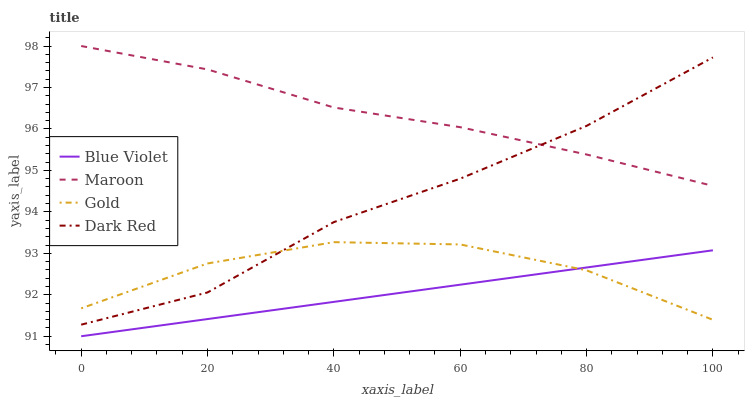Does Maroon have the minimum area under the curve?
Answer yes or no. No. Does Blue Violet have the maximum area under the curve?
Answer yes or no. No. Is Maroon the smoothest?
Answer yes or no. No. Is Maroon the roughest?
Answer yes or no. No. Does Maroon have the lowest value?
Answer yes or no. No. Does Blue Violet have the highest value?
Answer yes or no. No. Is Blue Violet less than Maroon?
Answer yes or no. Yes. Is Dark Red greater than Blue Violet?
Answer yes or no. Yes. Does Blue Violet intersect Maroon?
Answer yes or no. No. 